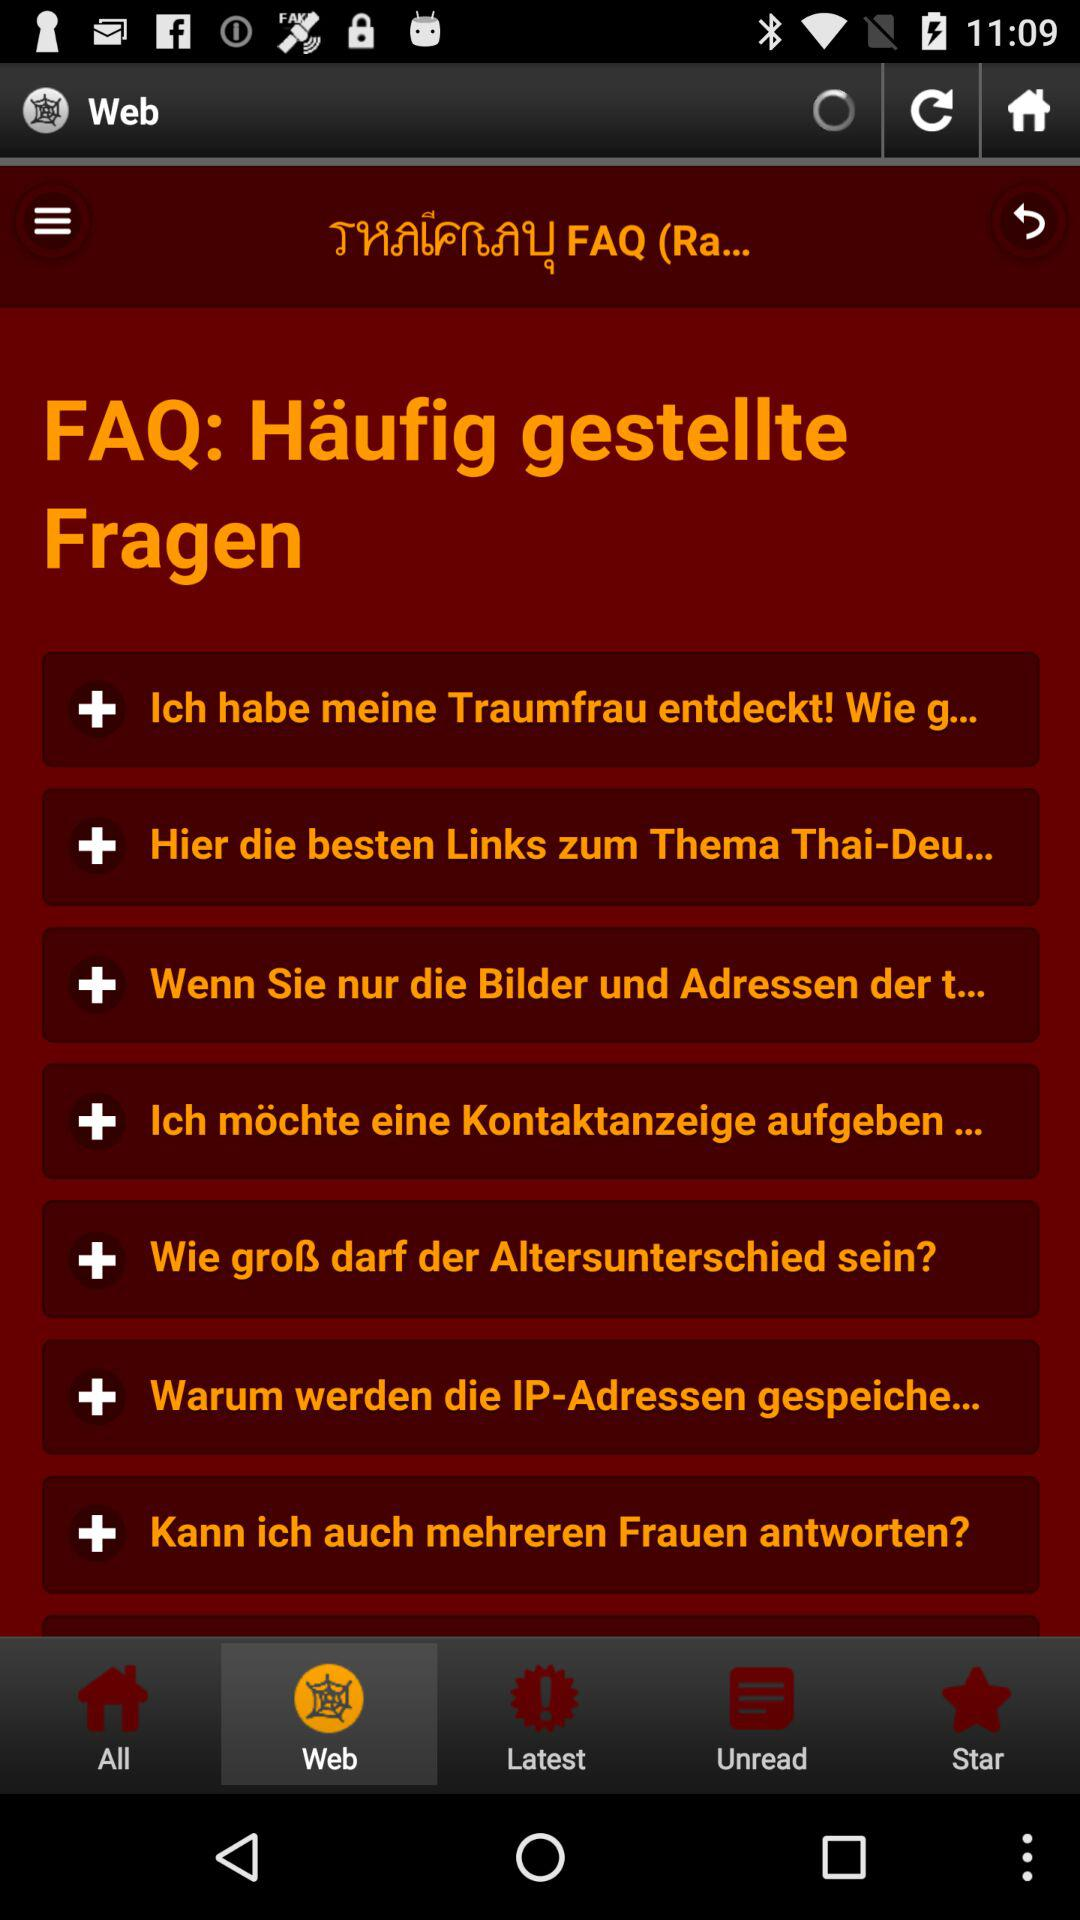Which tab is selected? The selected tab is "Web". 